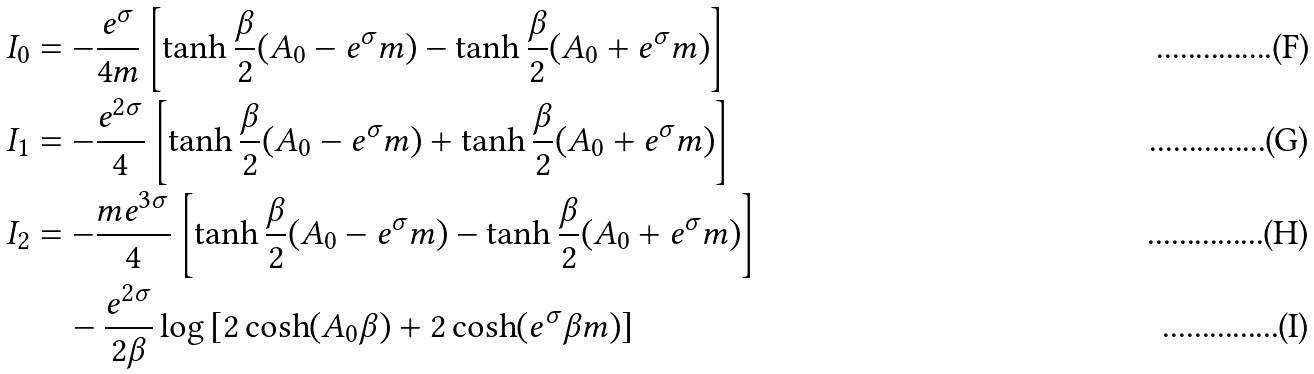Convert formula to latex. <formula><loc_0><loc_0><loc_500><loc_500>I _ { 0 } & = - \frac { e ^ { \sigma } } { 4 m } \left [ \tanh \frac { \beta } { 2 } ( A _ { 0 } - e ^ { \sigma } m ) - \tanh \frac { \beta } { 2 } ( A _ { 0 } + e ^ { \sigma } m ) \right ] \\ I _ { 1 } & = - \frac { e ^ { 2 \sigma } } { 4 } \left [ \tanh \frac { \beta } { 2 } ( A _ { 0 } - e ^ { \sigma } m ) + \tanh \frac { \beta } { 2 } ( A _ { 0 } + e ^ { \sigma } m ) \right ] \\ I _ { 2 } & = - \frac { m e ^ { 3 \sigma } } { 4 } \left [ \tanh \frac { \beta } { 2 } ( A _ { 0 } - e ^ { \sigma } m ) - \tanh \frac { \beta } { 2 } ( A _ { 0 } + e ^ { \sigma } m ) \right ] \\ & \quad - \frac { e ^ { 2 \sigma } } { 2 \beta } \log \left [ 2 \cosh ( A _ { 0 } \beta ) + 2 \cosh ( e ^ { \sigma } \beta m ) \right ]</formula> 